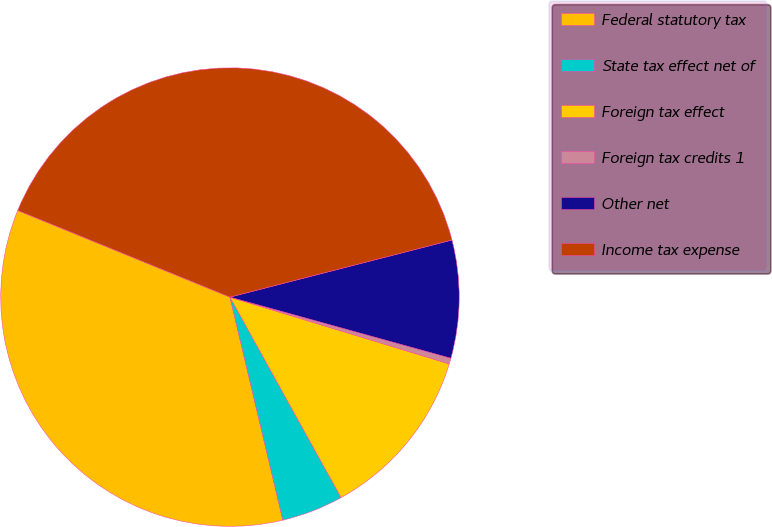Convert chart to OTSL. <chart><loc_0><loc_0><loc_500><loc_500><pie_chart><fcel>Federal statutory tax<fcel>State tax effect net of<fcel>Foreign tax effect<fcel>Foreign tax credits 1<fcel>Other net<fcel>Income tax expense<nl><fcel>34.88%<fcel>4.35%<fcel>12.24%<fcel>0.41%<fcel>8.3%<fcel>39.83%<nl></chart> 